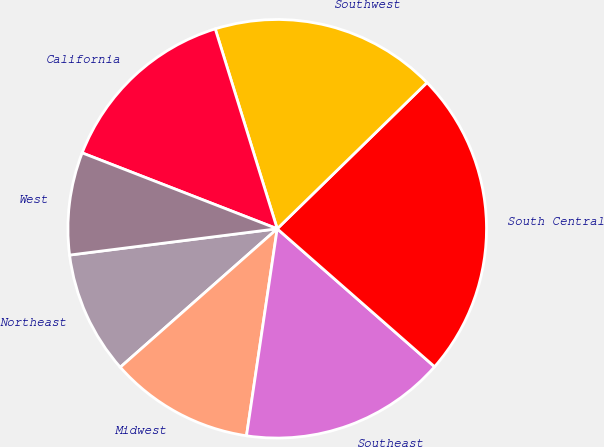Convert chart. <chart><loc_0><loc_0><loc_500><loc_500><pie_chart><fcel>Northeast<fcel>Midwest<fcel>Southeast<fcel>South Central<fcel>Southwest<fcel>California<fcel>West<nl><fcel>9.5%<fcel>11.15%<fcel>15.89%<fcel>23.76%<fcel>17.48%<fcel>14.31%<fcel>7.91%<nl></chart> 